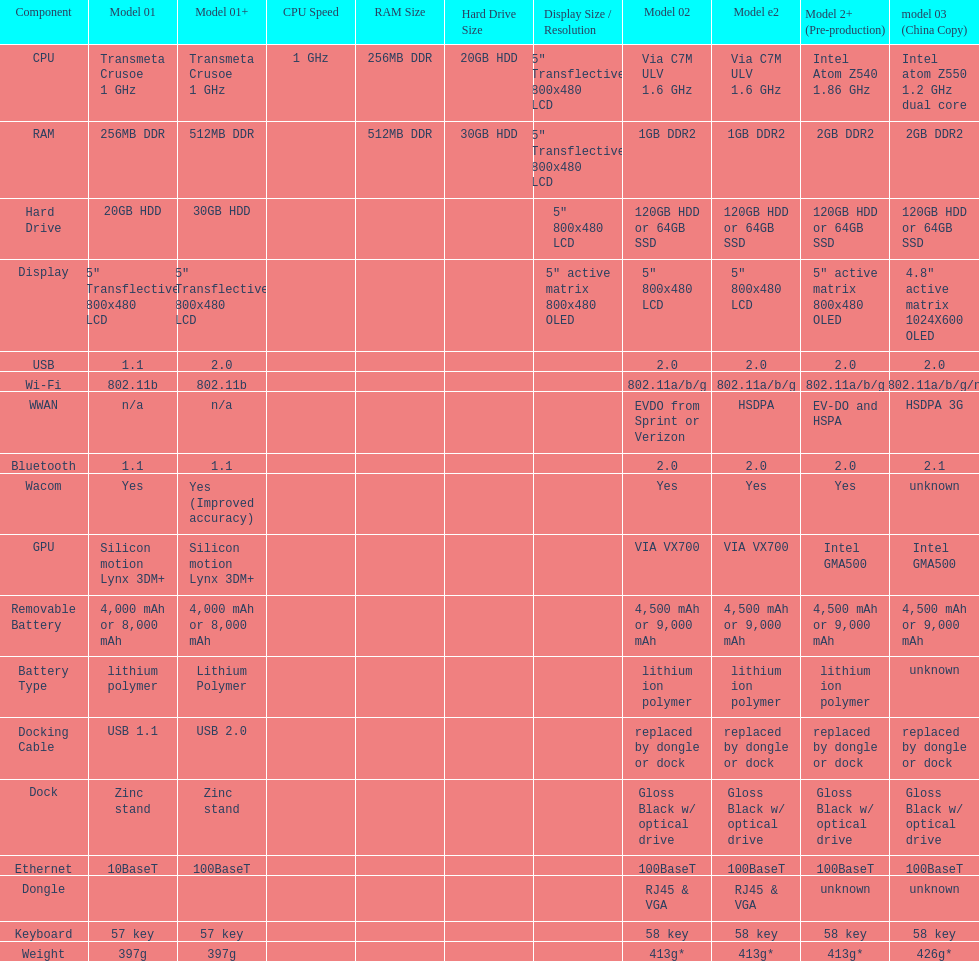What is the average number of models that have usb 2.0? 5. 